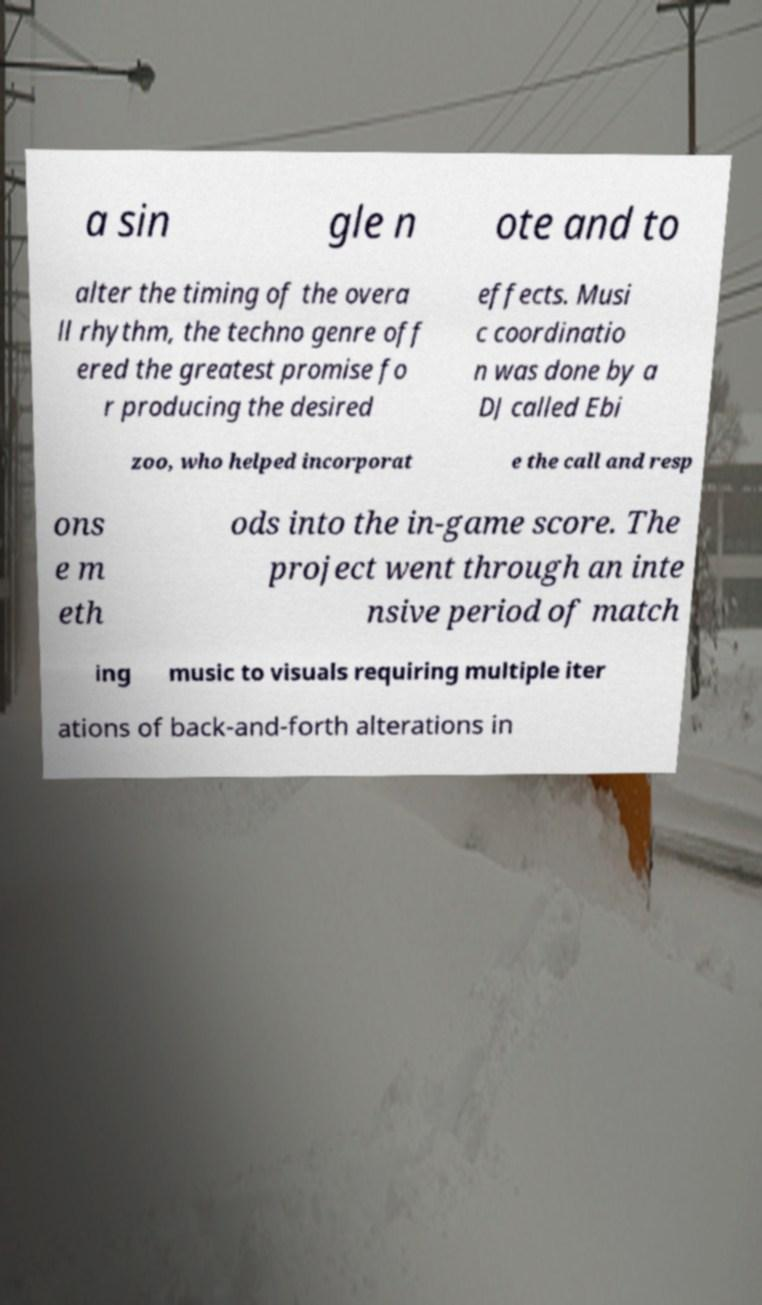Can you accurately transcribe the text from the provided image for me? a sin gle n ote and to alter the timing of the overa ll rhythm, the techno genre off ered the greatest promise fo r producing the desired effects. Musi c coordinatio n was done by a DJ called Ebi zoo, who helped incorporat e the call and resp ons e m eth ods into the in-game score. The project went through an inte nsive period of match ing music to visuals requiring multiple iter ations of back-and-forth alterations in 